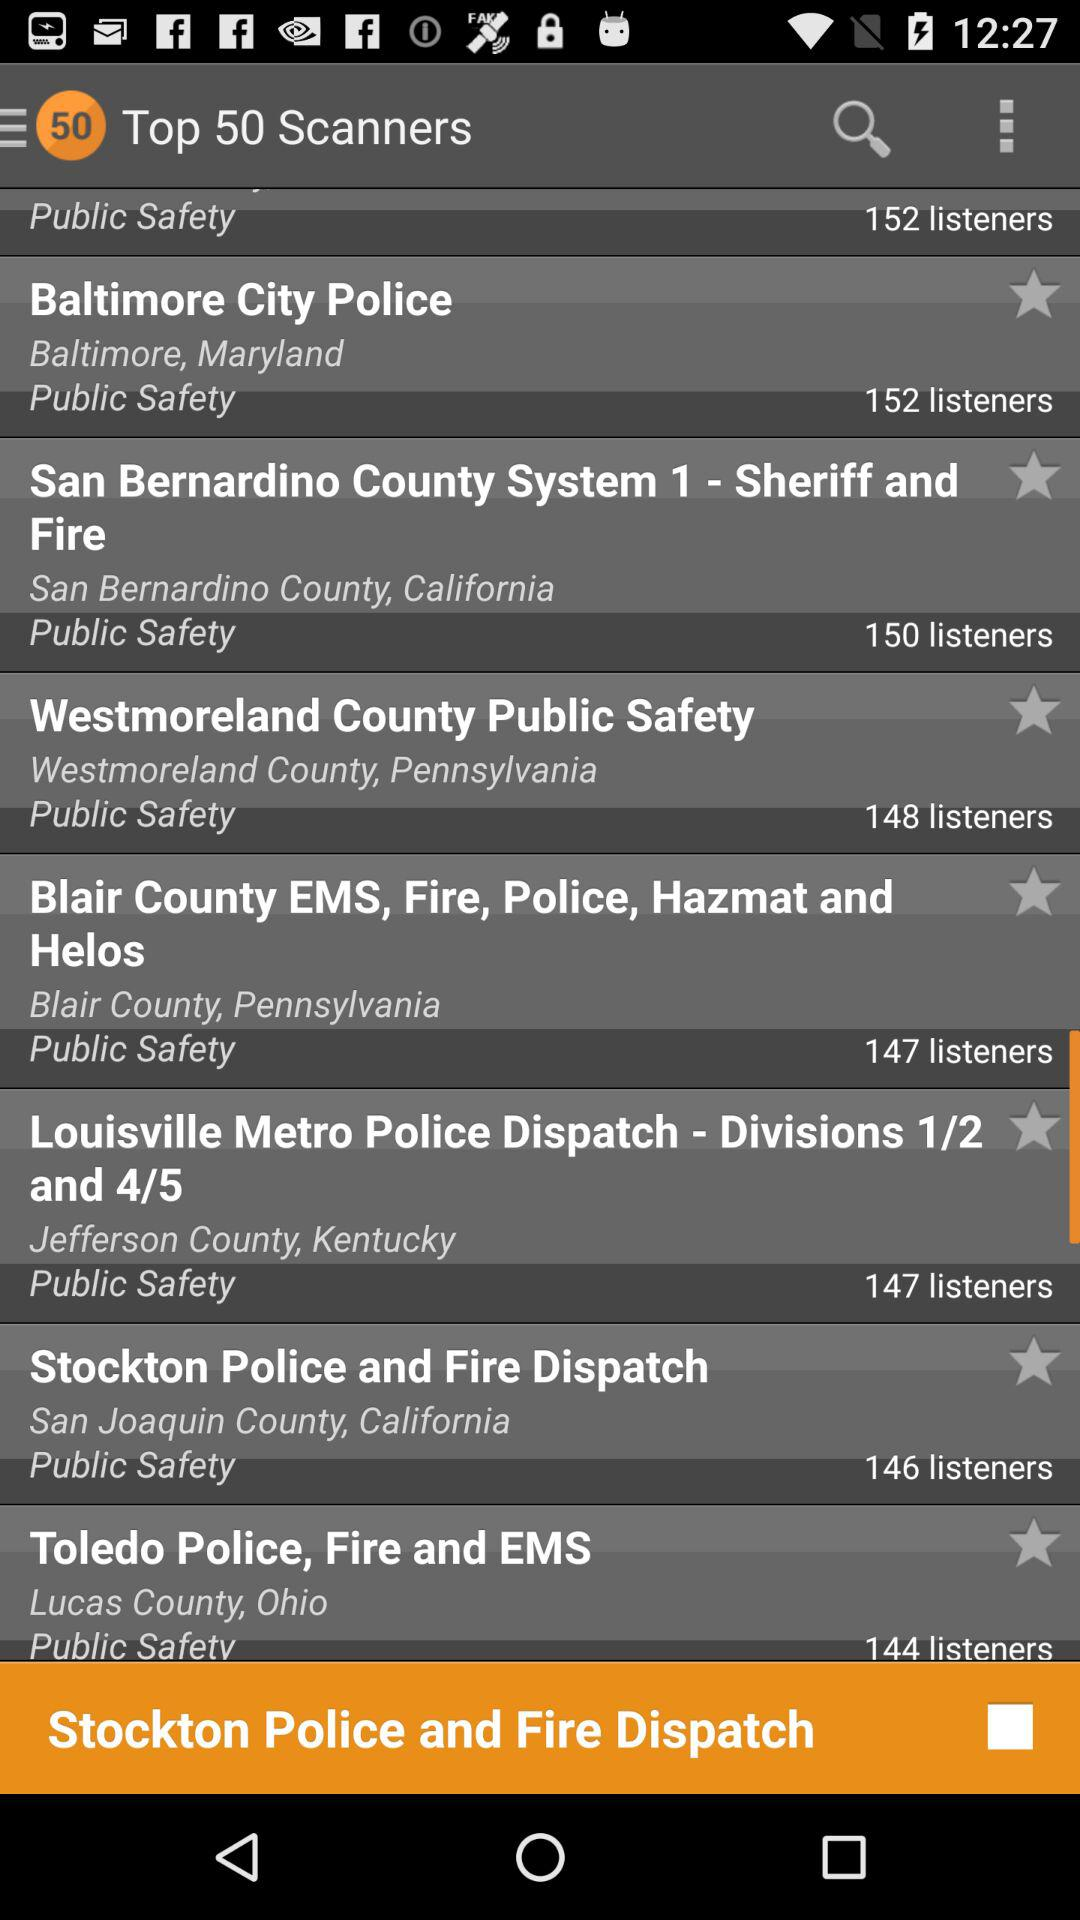How many listeners are there on "Stockton Police and Fire Dispatch"? There are 146 listeners. 